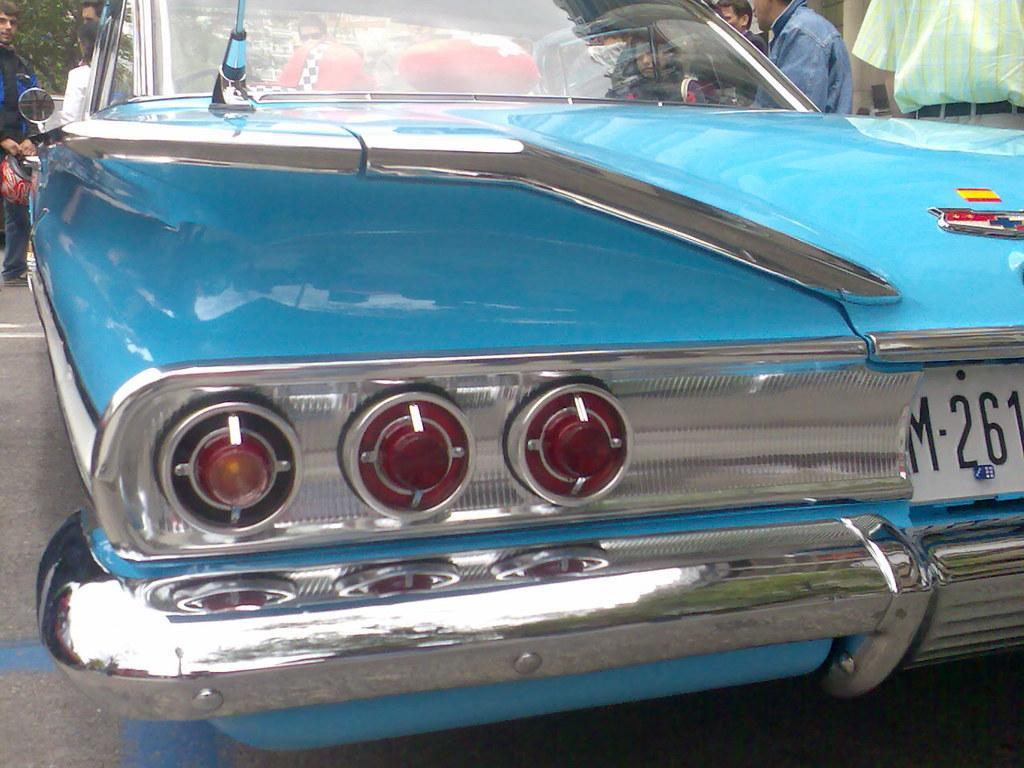Could you give a brief overview of what you see in this image? This picture shows a blue color car parked and we see few people standing and we see a man standing and holding a helmet in his hand and we see a tree. 